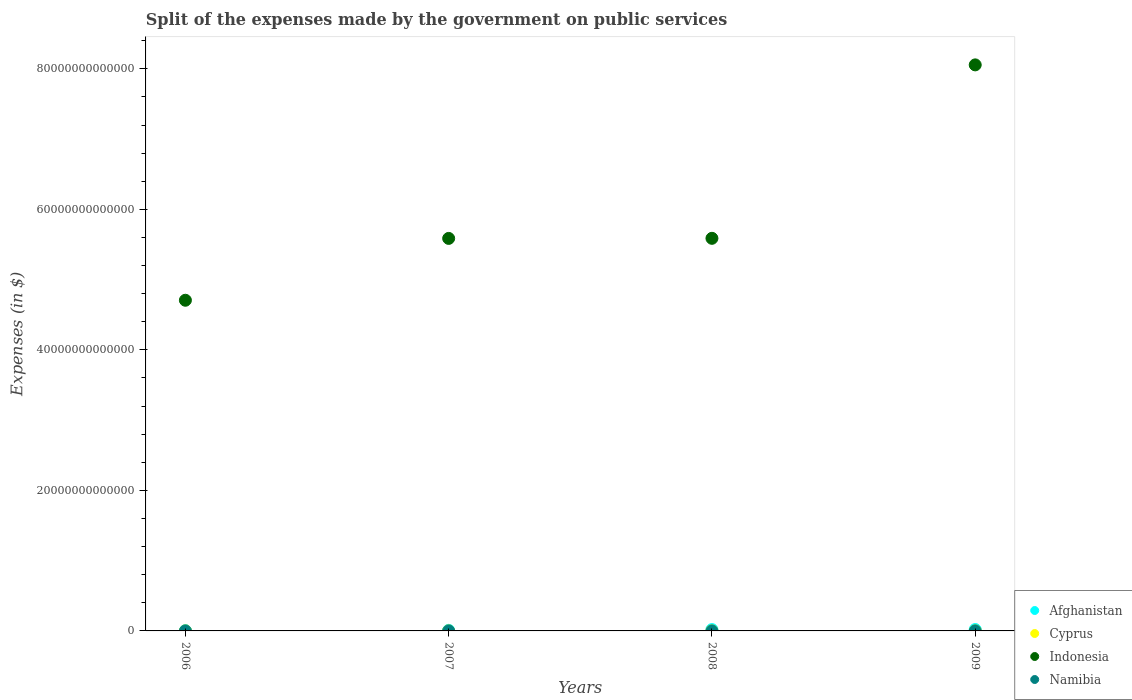How many different coloured dotlines are there?
Make the answer very short. 4. Is the number of dotlines equal to the number of legend labels?
Your response must be concise. Yes. What is the expenses made by the government on public services in Indonesia in 2006?
Provide a succinct answer. 4.71e+13. Across all years, what is the maximum expenses made by the government on public services in Cyprus?
Offer a terse response. 1.33e+09. Across all years, what is the minimum expenses made by the government on public services in Afghanistan?
Offer a terse response. 4.10e+1. What is the total expenses made by the government on public services in Namibia in the graph?
Offer a very short reply. 1.37e+1. What is the difference between the expenses made by the government on public services in Afghanistan in 2006 and that in 2009?
Offer a very short reply. -1.53e+11. What is the difference between the expenses made by the government on public services in Namibia in 2008 and the expenses made by the government on public services in Cyprus in 2007?
Give a very brief answer. 2.72e+09. What is the average expenses made by the government on public services in Cyprus per year?
Your answer should be very brief. 1.15e+09. In the year 2008, what is the difference between the expenses made by the government on public services in Namibia and expenses made by the government on public services in Indonesia?
Your answer should be very brief. -5.59e+13. In how many years, is the expenses made by the government on public services in Cyprus greater than 36000000000000 $?
Offer a terse response. 0. What is the ratio of the expenses made by the government on public services in Namibia in 2006 to that in 2009?
Ensure brevity in your answer.  0.47. Is the expenses made by the government on public services in Namibia in 2006 less than that in 2009?
Provide a short and direct response. Yes. Is the difference between the expenses made by the government on public services in Namibia in 2006 and 2008 greater than the difference between the expenses made by the government on public services in Indonesia in 2006 and 2008?
Keep it short and to the point. Yes. What is the difference between the highest and the second highest expenses made by the government on public services in Cyprus?
Offer a very short reply. 7.07e+07. What is the difference between the highest and the lowest expenses made by the government on public services in Afghanistan?
Make the answer very short. 1.53e+11. In how many years, is the expenses made by the government on public services in Afghanistan greater than the average expenses made by the government on public services in Afghanistan taken over all years?
Give a very brief answer. 2. Is the sum of the expenses made by the government on public services in Namibia in 2006 and 2008 greater than the maximum expenses made by the government on public services in Indonesia across all years?
Provide a succinct answer. No. Is it the case that in every year, the sum of the expenses made by the government on public services in Afghanistan and expenses made by the government on public services in Indonesia  is greater than the sum of expenses made by the government on public services in Cyprus and expenses made by the government on public services in Namibia?
Your answer should be compact. No. Is it the case that in every year, the sum of the expenses made by the government on public services in Afghanistan and expenses made by the government on public services in Namibia  is greater than the expenses made by the government on public services in Cyprus?
Your answer should be very brief. Yes. Does the expenses made by the government on public services in Namibia monotonically increase over the years?
Make the answer very short. Yes. Is the expenses made by the government on public services in Indonesia strictly less than the expenses made by the government on public services in Cyprus over the years?
Your answer should be compact. No. How many dotlines are there?
Ensure brevity in your answer.  4. How many years are there in the graph?
Provide a succinct answer. 4. What is the difference between two consecutive major ticks on the Y-axis?
Provide a succinct answer. 2.00e+13. Are the values on the major ticks of Y-axis written in scientific E-notation?
Offer a terse response. No. Where does the legend appear in the graph?
Keep it short and to the point. Bottom right. What is the title of the graph?
Your answer should be very brief. Split of the expenses made by the government on public services. What is the label or title of the Y-axis?
Your answer should be very brief. Expenses (in $). What is the Expenses (in $) in Afghanistan in 2006?
Provide a succinct answer. 4.10e+1. What is the Expenses (in $) in Cyprus in 2006?
Your answer should be compact. 1.26e+09. What is the Expenses (in $) in Indonesia in 2006?
Your answer should be very brief. 4.71e+13. What is the Expenses (in $) in Namibia in 2006?
Ensure brevity in your answer.  2.17e+09. What is the Expenses (in $) of Afghanistan in 2007?
Provide a succinct answer. 7.84e+1. What is the Expenses (in $) in Cyprus in 2007?
Provide a succinct answer. 1.17e+09. What is the Expenses (in $) in Indonesia in 2007?
Your answer should be very brief. 5.59e+13. What is the Expenses (in $) of Namibia in 2007?
Your answer should be very brief. 3.00e+09. What is the Expenses (in $) of Afghanistan in 2008?
Give a very brief answer. 1.89e+11. What is the Expenses (in $) of Cyprus in 2008?
Your response must be concise. 1.33e+09. What is the Expenses (in $) in Indonesia in 2008?
Provide a short and direct response. 5.59e+13. What is the Expenses (in $) in Namibia in 2008?
Make the answer very short. 3.89e+09. What is the Expenses (in $) of Afghanistan in 2009?
Ensure brevity in your answer.  1.94e+11. What is the Expenses (in $) of Cyprus in 2009?
Keep it short and to the point. 8.23e+08. What is the Expenses (in $) of Indonesia in 2009?
Offer a very short reply. 8.06e+13. What is the Expenses (in $) in Namibia in 2009?
Give a very brief answer. 4.65e+09. Across all years, what is the maximum Expenses (in $) of Afghanistan?
Your response must be concise. 1.94e+11. Across all years, what is the maximum Expenses (in $) in Cyprus?
Your answer should be compact. 1.33e+09. Across all years, what is the maximum Expenses (in $) of Indonesia?
Your response must be concise. 8.06e+13. Across all years, what is the maximum Expenses (in $) of Namibia?
Your answer should be very brief. 4.65e+09. Across all years, what is the minimum Expenses (in $) in Afghanistan?
Your response must be concise. 4.10e+1. Across all years, what is the minimum Expenses (in $) in Cyprus?
Make the answer very short. 8.23e+08. Across all years, what is the minimum Expenses (in $) of Indonesia?
Your answer should be very brief. 4.71e+13. Across all years, what is the minimum Expenses (in $) in Namibia?
Your answer should be very brief. 2.17e+09. What is the total Expenses (in $) of Afghanistan in the graph?
Make the answer very short. 5.03e+11. What is the total Expenses (in $) of Cyprus in the graph?
Offer a very short reply. 4.59e+09. What is the total Expenses (in $) in Indonesia in the graph?
Keep it short and to the point. 2.39e+14. What is the total Expenses (in $) of Namibia in the graph?
Provide a succinct answer. 1.37e+1. What is the difference between the Expenses (in $) in Afghanistan in 2006 and that in 2007?
Offer a very short reply. -3.74e+1. What is the difference between the Expenses (in $) in Cyprus in 2006 and that in 2007?
Provide a short and direct response. 9.14e+07. What is the difference between the Expenses (in $) in Indonesia in 2006 and that in 2007?
Offer a very short reply. -8.80e+12. What is the difference between the Expenses (in $) in Namibia in 2006 and that in 2007?
Keep it short and to the point. -8.32e+08. What is the difference between the Expenses (in $) in Afghanistan in 2006 and that in 2008?
Give a very brief answer. -1.48e+11. What is the difference between the Expenses (in $) in Cyprus in 2006 and that in 2008?
Offer a very short reply. -7.07e+07. What is the difference between the Expenses (in $) of Indonesia in 2006 and that in 2008?
Offer a terse response. -8.81e+12. What is the difference between the Expenses (in $) in Namibia in 2006 and that in 2008?
Make the answer very short. -1.72e+09. What is the difference between the Expenses (in $) in Afghanistan in 2006 and that in 2009?
Offer a terse response. -1.53e+11. What is the difference between the Expenses (in $) in Cyprus in 2006 and that in 2009?
Your answer should be compact. 4.40e+08. What is the difference between the Expenses (in $) of Indonesia in 2006 and that in 2009?
Your answer should be compact. -3.35e+13. What is the difference between the Expenses (in $) in Namibia in 2006 and that in 2009?
Your answer should be compact. -2.48e+09. What is the difference between the Expenses (in $) in Afghanistan in 2007 and that in 2008?
Your answer should be compact. -1.11e+11. What is the difference between the Expenses (in $) in Cyprus in 2007 and that in 2008?
Keep it short and to the point. -1.62e+08. What is the difference between the Expenses (in $) of Indonesia in 2007 and that in 2008?
Your answer should be very brief. -1.24e+1. What is the difference between the Expenses (in $) of Namibia in 2007 and that in 2008?
Ensure brevity in your answer.  -8.89e+08. What is the difference between the Expenses (in $) in Afghanistan in 2007 and that in 2009?
Provide a succinct answer. -1.16e+11. What is the difference between the Expenses (in $) of Cyprus in 2007 and that in 2009?
Keep it short and to the point. 3.48e+08. What is the difference between the Expenses (in $) in Indonesia in 2007 and that in 2009?
Offer a terse response. -2.47e+13. What is the difference between the Expenses (in $) in Namibia in 2007 and that in 2009?
Your response must be concise. -1.65e+09. What is the difference between the Expenses (in $) in Afghanistan in 2008 and that in 2009?
Give a very brief answer. -5.15e+09. What is the difference between the Expenses (in $) in Cyprus in 2008 and that in 2009?
Make the answer very short. 5.10e+08. What is the difference between the Expenses (in $) of Indonesia in 2008 and that in 2009?
Your response must be concise. -2.47e+13. What is the difference between the Expenses (in $) in Namibia in 2008 and that in 2009?
Provide a short and direct response. -7.61e+08. What is the difference between the Expenses (in $) in Afghanistan in 2006 and the Expenses (in $) in Cyprus in 2007?
Ensure brevity in your answer.  3.98e+1. What is the difference between the Expenses (in $) of Afghanistan in 2006 and the Expenses (in $) of Indonesia in 2007?
Ensure brevity in your answer.  -5.58e+13. What is the difference between the Expenses (in $) of Afghanistan in 2006 and the Expenses (in $) of Namibia in 2007?
Your answer should be compact. 3.80e+1. What is the difference between the Expenses (in $) in Cyprus in 2006 and the Expenses (in $) in Indonesia in 2007?
Make the answer very short. -5.59e+13. What is the difference between the Expenses (in $) in Cyprus in 2006 and the Expenses (in $) in Namibia in 2007?
Offer a very short reply. -1.73e+09. What is the difference between the Expenses (in $) of Indonesia in 2006 and the Expenses (in $) of Namibia in 2007?
Provide a short and direct response. 4.71e+13. What is the difference between the Expenses (in $) of Afghanistan in 2006 and the Expenses (in $) of Cyprus in 2008?
Provide a succinct answer. 3.96e+1. What is the difference between the Expenses (in $) of Afghanistan in 2006 and the Expenses (in $) of Indonesia in 2008?
Keep it short and to the point. -5.58e+13. What is the difference between the Expenses (in $) of Afghanistan in 2006 and the Expenses (in $) of Namibia in 2008?
Your answer should be compact. 3.71e+1. What is the difference between the Expenses (in $) in Cyprus in 2006 and the Expenses (in $) in Indonesia in 2008?
Your answer should be compact. -5.59e+13. What is the difference between the Expenses (in $) in Cyprus in 2006 and the Expenses (in $) in Namibia in 2008?
Make the answer very short. -2.62e+09. What is the difference between the Expenses (in $) of Indonesia in 2006 and the Expenses (in $) of Namibia in 2008?
Ensure brevity in your answer.  4.71e+13. What is the difference between the Expenses (in $) of Afghanistan in 2006 and the Expenses (in $) of Cyprus in 2009?
Give a very brief answer. 4.02e+1. What is the difference between the Expenses (in $) in Afghanistan in 2006 and the Expenses (in $) in Indonesia in 2009?
Provide a short and direct response. -8.05e+13. What is the difference between the Expenses (in $) of Afghanistan in 2006 and the Expenses (in $) of Namibia in 2009?
Provide a short and direct response. 3.63e+1. What is the difference between the Expenses (in $) of Cyprus in 2006 and the Expenses (in $) of Indonesia in 2009?
Provide a short and direct response. -8.06e+13. What is the difference between the Expenses (in $) of Cyprus in 2006 and the Expenses (in $) of Namibia in 2009?
Ensure brevity in your answer.  -3.38e+09. What is the difference between the Expenses (in $) in Indonesia in 2006 and the Expenses (in $) in Namibia in 2009?
Ensure brevity in your answer.  4.71e+13. What is the difference between the Expenses (in $) of Afghanistan in 2007 and the Expenses (in $) of Cyprus in 2008?
Your answer should be compact. 7.70e+1. What is the difference between the Expenses (in $) in Afghanistan in 2007 and the Expenses (in $) in Indonesia in 2008?
Ensure brevity in your answer.  -5.58e+13. What is the difference between the Expenses (in $) in Afghanistan in 2007 and the Expenses (in $) in Namibia in 2008?
Your answer should be very brief. 7.45e+1. What is the difference between the Expenses (in $) of Cyprus in 2007 and the Expenses (in $) of Indonesia in 2008?
Offer a terse response. -5.59e+13. What is the difference between the Expenses (in $) of Cyprus in 2007 and the Expenses (in $) of Namibia in 2008?
Your answer should be compact. -2.72e+09. What is the difference between the Expenses (in $) in Indonesia in 2007 and the Expenses (in $) in Namibia in 2008?
Provide a short and direct response. 5.59e+13. What is the difference between the Expenses (in $) of Afghanistan in 2007 and the Expenses (in $) of Cyprus in 2009?
Give a very brief answer. 7.75e+1. What is the difference between the Expenses (in $) of Afghanistan in 2007 and the Expenses (in $) of Indonesia in 2009?
Provide a short and direct response. -8.05e+13. What is the difference between the Expenses (in $) of Afghanistan in 2007 and the Expenses (in $) of Namibia in 2009?
Make the answer very short. 7.37e+1. What is the difference between the Expenses (in $) in Cyprus in 2007 and the Expenses (in $) in Indonesia in 2009?
Give a very brief answer. -8.06e+13. What is the difference between the Expenses (in $) in Cyprus in 2007 and the Expenses (in $) in Namibia in 2009?
Your answer should be very brief. -3.48e+09. What is the difference between the Expenses (in $) of Indonesia in 2007 and the Expenses (in $) of Namibia in 2009?
Provide a succinct answer. 5.59e+13. What is the difference between the Expenses (in $) in Afghanistan in 2008 and the Expenses (in $) in Cyprus in 2009?
Your answer should be very brief. 1.88e+11. What is the difference between the Expenses (in $) in Afghanistan in 2008 and the Expenses (in $) in Indonesia in 2009?
Provide a succinct answer. -8.04e+13. What is the difference between the Expenses (in $) of Afghanistan in 2008 and the Expenses (in $) of Namibia in 2009?
Provide a short and direct response. 1.85e+11. What is the difference between the Expenses (in $) of Cyprus in 2008 and the Expenses (in $) of Indonesia in 2009?
Your answer should be very brief. -8.06e+13. What is the difference between the Expenses (in $) in Cyprus in 2008 and the Expenses (in $) in Namibia in 2009?
Your answer should be compact. -3.31e+09. What is the difference between the Expenses (in $) of Indonesia in 2008 and the Expenses (in $) of Namibia in 2009?
Offer a very short reply. 5.59e+13. What is the average Expenses (in $) of Afghanistan per year?
Provide a short and direct response. 1.26e+11. What is the average Expenses (in $) in Cyprus per year?
Provide a short and direct response. 1.15e+09. What is the average Expenses (in $) in Indonesia per year?
Your response must be concise. 5.98e+13. What is the average Expenses (in $) of Namibia per year?
Make the answer very short. 3.42e+09. In the year 2006, what is the difference between the Expenses (in $) in Afghanistan and Expenses (in $) in Cyprus?
Offer a very short reply. 3.97e+1. In the year 2006, what is the difference between the Expenses (in $) in Afghanistan and Expenses (in $) in Indonesia?
Ensure brevity in your answer.  -4.70e+13. In the year 2006, what is the difference between the Expenses (in $) in Afghanistan and Expenses (in $) in Namibia?
Your answer should be compact. 3.88e+1. In the year 2006, what is the difference between the Expenses (in $) of Cyprus and Expenses (in $) of Indonesia?
Give a very brief answer. -4.71e+13. In the year 2006, what is the difference between the Expenses (in $) of Cyprus and Expenses (in $) of Namibia?
Keep it short and to the point. -9.03e+08. In the year 2006, what is the difference between the Expenses (in $) in Indonesia and Expenses (in $) in Namibia?
Provide a short and direct response. 4.71e+13. In the year 2007, what is the difference between the Expenses (in $) in Afghanistan and Expenses (in $) in Cyprus?
Your response must be concise. 7.72e+1. In the year 2007, what is the difference between the Expenses (in $) of Afghanistan and Expenses (in $) of Indonesia?
Your response must be concise. -5.58e+13. In the year 2007, what is the difference between the Expenses (in $) in Afghanistan and Expenses (in $) in Namibia?
Ensure brevity in your answer.  7.54e+1. In the year 2007, what is the difference between the Expenses (in $) of Cyprus and Expenses (in $) of Indonesia?
Provide a short and direct response. -5.59e+13. In the year 2007, what is the difference between the Expenses (in $) in Cyprus and Expenses (in $) in Namibia?
Provide a succinct answer. -1.83e+09. In the year 2007, what is the difference between the Expenses (in $) of Indonesia and Expenses (in $) of Namibia?
Ensure brevity in your answer.  5.59e+13. In the year 2008, what is the difference between the Expenses (in $) of Afghanistan and Expenses (in $) of Cyprus?
Make the answer very short. 1.88e+11. In the year 2008, what is the difference between the Expenses (in $) in Afghanistan and Expenses (in $) in Indonesia?
Provide a short and direct response. -5.57e+13. In the year 2008, what is the difference between the Expenses (in $) of Afghanistan and Expenses (in $) of Namibia?
Ensure brevity in your answer.  1.85e+11. In the year 2008, what is the difference between the Expenses (in $) in Cyprus and Expenses (in $) in Indonesia?
Your answer should be very brief. -5.59e+13. In the year 2008, what is the difference between the Expenses (in $) of Cyprus and Expenses (in $) of Namibia?
Give a very brief answer. -2.55e+09. In the year 2008, what is the difference between the Expenses (in $) of Indonesia and Expenses (in $) of Namibia?
Give a very brief answer. 5.59e+13. In the year 2009, what is the difference between the Expenses (in $) of Afghanistan and Expenses (in $) of Cyprus?
Offer a terse response. 1.94e+11. In the year 2009, what is the difference between the Expenses (in $) in Afghanistan and Expenses (in $) in Indonesia?
Ensure brevity in your answer.  -8.04e+13. In the year 2009, what is the difference between the Expenses (in $) of Afghanistan and Expenses (in $) of Namibia?
Give a very brief answer. 1.90e+11. In the year 2009, what is the difference between the Expenses (in $) of Cyprus and Expenses (in $) of Indonesia?
Offer a very short reply. -8.06e+13. In the year 2009, what is the difference between the Expenses (in $) of Cyprus and Expenses (in $) of Namibia?
Provide a short and direct response. -3.82e+09. In the year 2009, what is the difference between the Expenses (in $) in Indonesia and Expenses (in $) in Namibia?
Give a very brief answer. 8.06e+13. What is the ratio of the Expenses (in $) in Afghanistan in 2006 to that in 2007?
Your answer should be very brief. 0.52. What is the ratio of the Expenses (in $) in Cyprus in 2006 to that in 2007?
Make the answer very short. 1.08. What is the ratio of the Expenses (in $) in Indonesia in 2006 to that in 2007?
Provide a succinct answer. 0.84. What is the ratio of the Expenses (in $) of Namibia in 2006 to that in 2007?
Your answer should be compact. 0.72. What is the ratio of the Expenses (in $) in Afghanistan in 2006 to that in 2008?
Offer a very short reply. 0.22. What is the ratio of the Expenses (in $) in Cyprus in 2006 to that in 2008?
Offer a terse response. 0.95. What is the ratio of the Expenses (in $) in Indonesia in 2006 to that in 2008?
Your answer should be compact. 0.84. What is the ratio of the Expenses (in $) in Namibia in 2006 to that in 2008?
Keep it short and to the point. 0.56. What is the ratio of the Expenses (in $) in Afghanistan in 2006 to that in 2009?
Provide a short and direct response. 0.21. What is the ratio of the Expenses (in $) of Cyprus in 2006 to that in 2009?
Ensure brevity in your answer.  1.53. What is the ratio of the Expenses (in $) of Indonesia in 2006 to that in 2009?
Offer a terse response. 0.58. What is the ratio of the Expenses (in $) in Namibia in 2006 to that in 2009?
Provide a succinct answer. 0.47. What is the ratio of the Expenses (in $) in Afghanistan in 2007 to that in 2008?
Provide a succinct answer. 0.41. What is the ratio of the Expenses (in $) in Cyprus in 2007 to that in 2008?
Provide a succinct answer. 0.88. What is the ratio of the Expenses (in $) in Namibia in 2007 to that in 2008?
Make the answer very short. 0.77. What is the ratio of the Expenses (in $) of Afghanistan in 2007 to that in 2009?
Offer a very short reply. 0.4. What is the ratio of the Expenses (in $) of Cyprus in 2007 to that in 2009?
Make the answer very short. 1.42. What is the ratio of the Expenses (in $) in Indonesia in 2007 to that in 2009?
Ensure brevity in your answer.  0.69. What is the ratio of the Expenses (in $) in Namibia in 2007 to that in 2009?
Ensure brevity in your answer.  0.64. What is the ratio of the Expenses (in $) in Afghanistan in 2008 to that in 2009?
Keep it short and to the point. 0.97. What is the ratio of the Expenses (in $) of Cyprus in 2008 to that in 2009?
Make the answer very short. 1.62. What is the ratio of the Expenses (in $) of Indonesia in 2008 to that in 2009?
Your answer should be compact. 0.69. What is the ratio of the Expenses (in $) of Namibia in 2008 to that in 2009?
Your answer should be compact. 0.84. What is the difference between the highest and the second highest Expenses (in $) in Afghanistan?
Keep it short and to the point. 5.15e+09. What is the difference between the highest and the second highest Expenses (in $) in Cyprus?
Offer a terse response. 7.07e+07. What is the difference between the highest and the second highest Expenses (in $) in Indonesia?
Give a very brief answer. 2.47e+13. What is the difference between the highest and the second highest Expenses (in $) of Namibia?
Provide a succinct answer. 7.61e+08. What is the difference between the highest and the lowest Expenses (in $) of Afghanistan?
Ensure brevity in your answer.  1.53e+11. What is the difference between the highest and the lowest Expenses (in $) of Cyprus?
Make the answer very short. 5.10e+08. What is the difference between the highest and the lowest Expenses (in $) in Indonesia?
Offer a very short reply. 3.35e+13. What is the difference between the highest and the lowest Expenses (in $) in Namibia?
Offer a very short reply. 2.48e+09. 